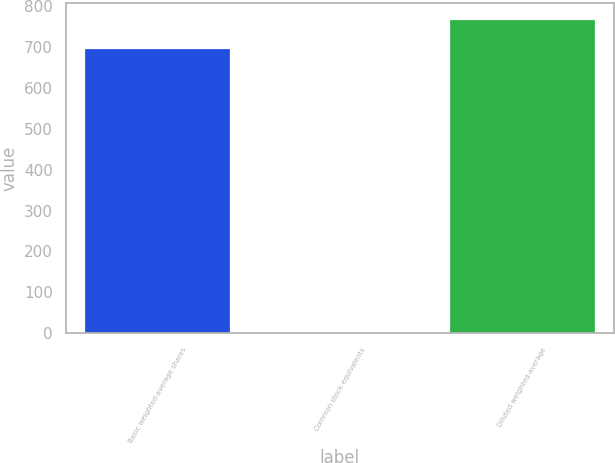<chart> <loc_0><loc_0><loc_500><loc_500><bar_chart><fcel>Basic weighted-average shares<fcel>Common stock equivalents<fcel>Diluted weighted-average<nl><fcel>698.9<fcel>2.1<fcel>768.79<nl></chart> 